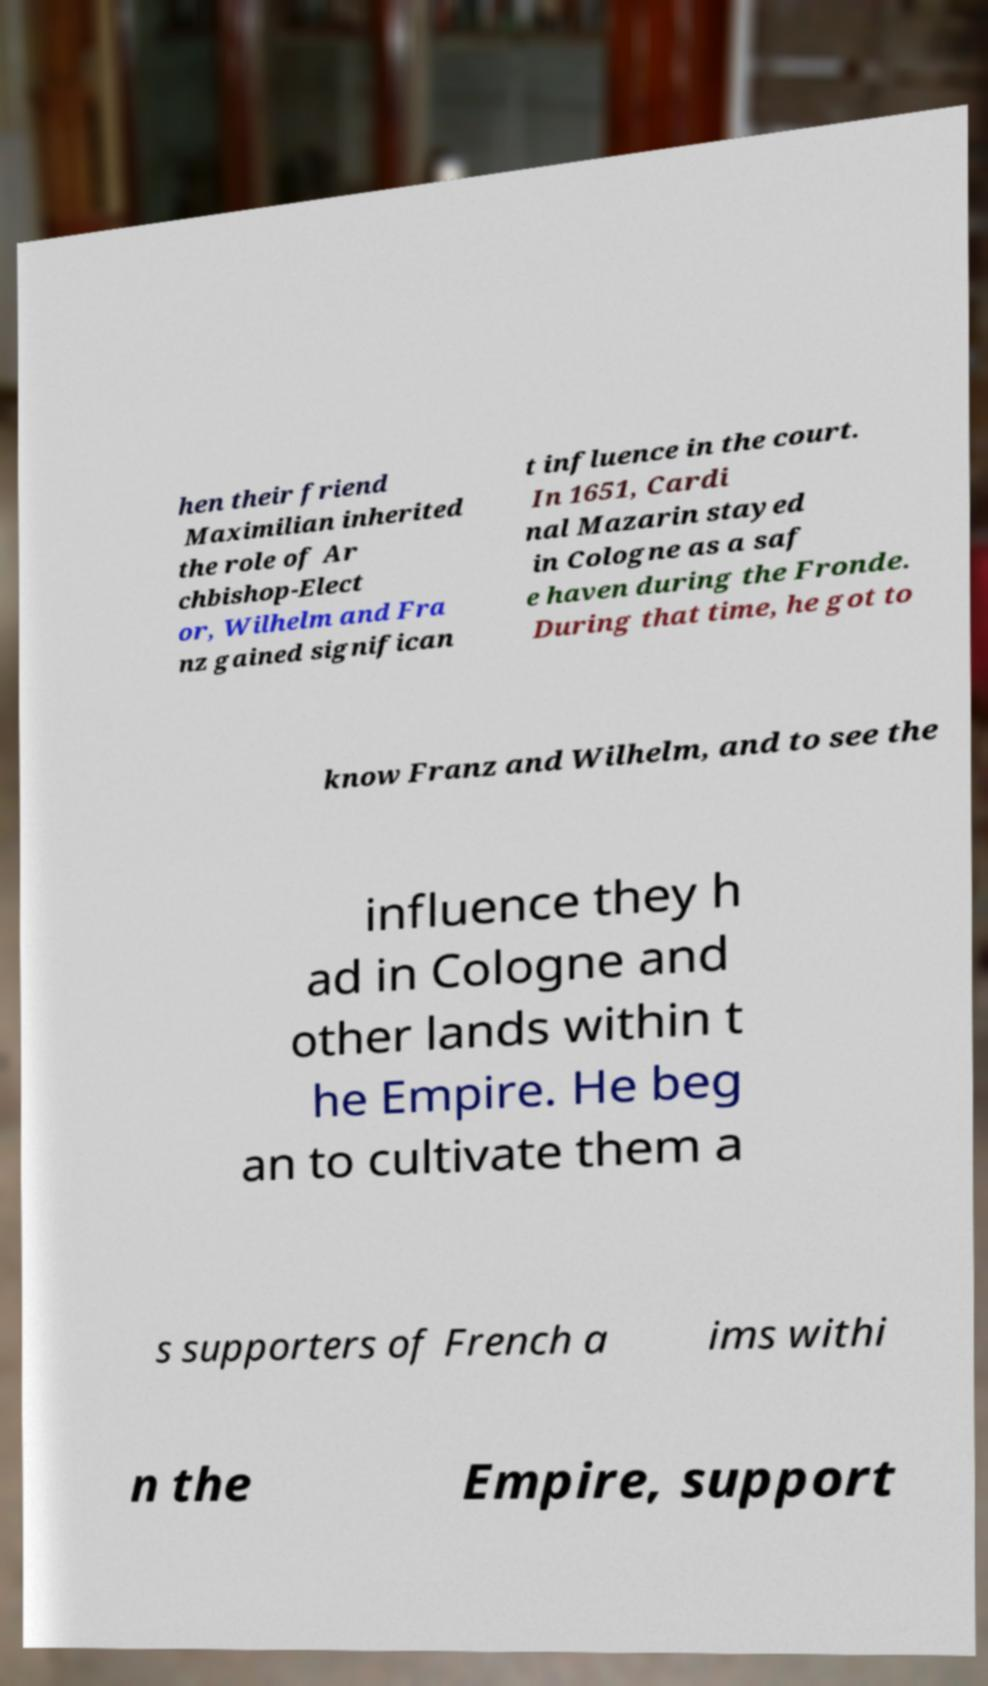Please read and relay the text visible in this image. What does it say? hen their friend Maximilian inherited the role of Ar chbishop-Elect or, Wilhelm and Fra nz gained significan t influence in the court. In 1651, Cardi nal Mazarin stayed in Cologne as a saf e haven during the Fronde. During that time, he got to know Franz and Wilhelm, and to see the influence they h ad in Cologne and other lands within t he Empire. He beg an to cultivate them a s supporters of French a ims withi n the Empire, support 